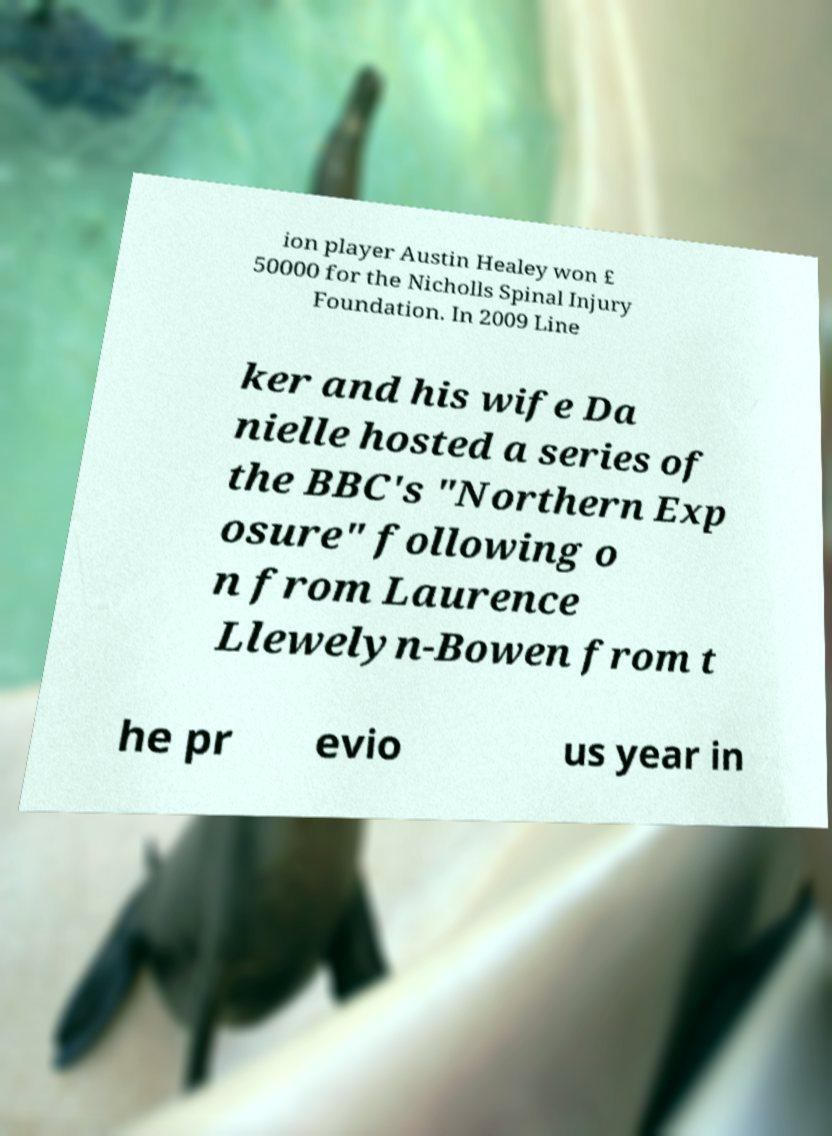For documentation purposes, I need the text within this image transcribed. Could you provide that? ion player Austin Healey won £ 50000 for the Nicholls Spinal Injury Foundation. In 2009 Line ker and his wife Da nielle hosted a series of the BBC's "Northern Exp osure" following o n from Laurence Llewelyn-Bowen from t he pr evio us year in 